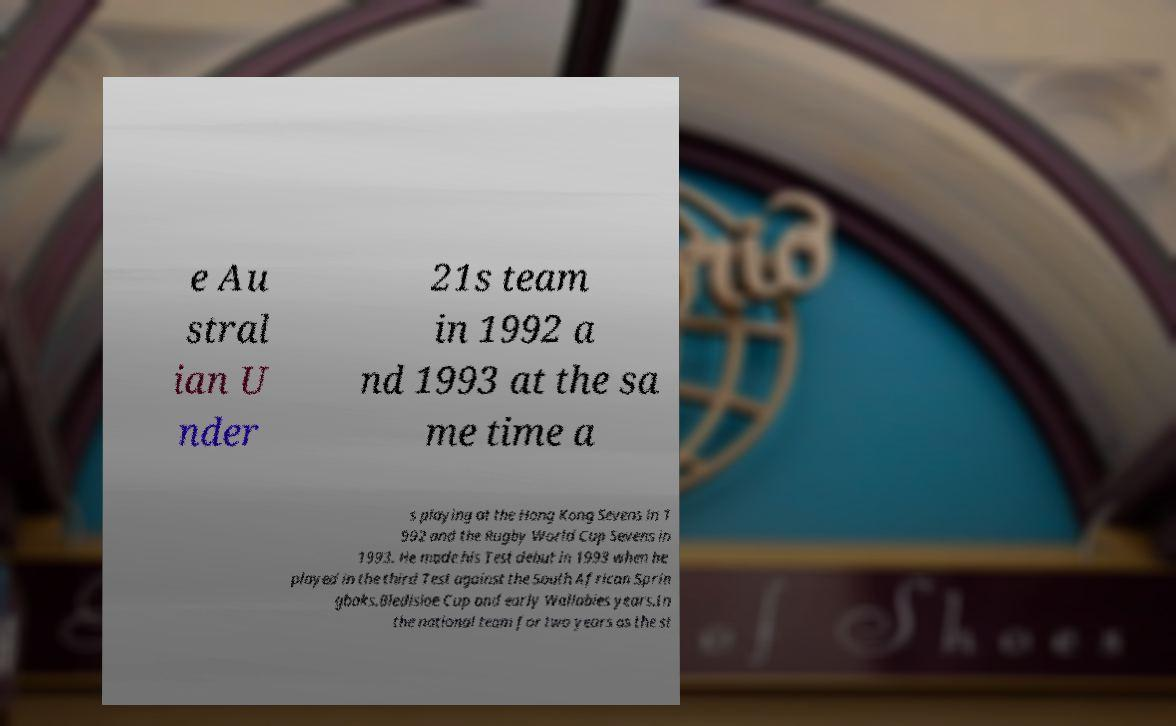Could you extract and type out the text from this image? e Au stral ian U nder 21s team in 1992 a nd 1993 at the sa me time a s playing at the Hong Kong Sevens in 1 992 and the Rugby World Cup Sevens in 1993. He made his Test debut in 1993 when he played in the third Test against the South African Sprin gboks.Bledisloe Cup and early Wallabies years.In the national team for two years as the st 